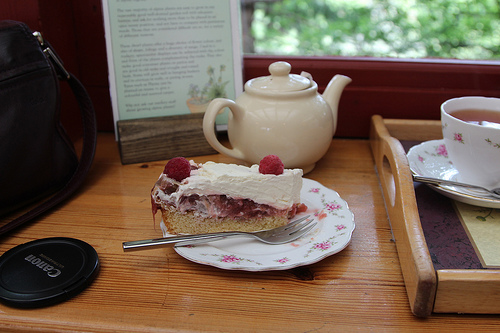<image>
Is the table on the fork? No. The table is not positioned on the fork. They may be near each other, but the table is not supported by or resting on top of the fork. Is the cake next to the teapot? Yes. The cake is positioned adjacent to the teapot, located nearby in the same general area. Where is the cake in relation to the teapot? Is it in front of the teapot? Yes. The cake is positioned in front of the teapot, appearing closer to the camera viewpoint. 